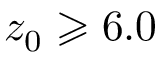<formula> <loc_0><loc_0><loc_500><loc_500>z _ { 0 } \geqslant 6 . 0</formula> 